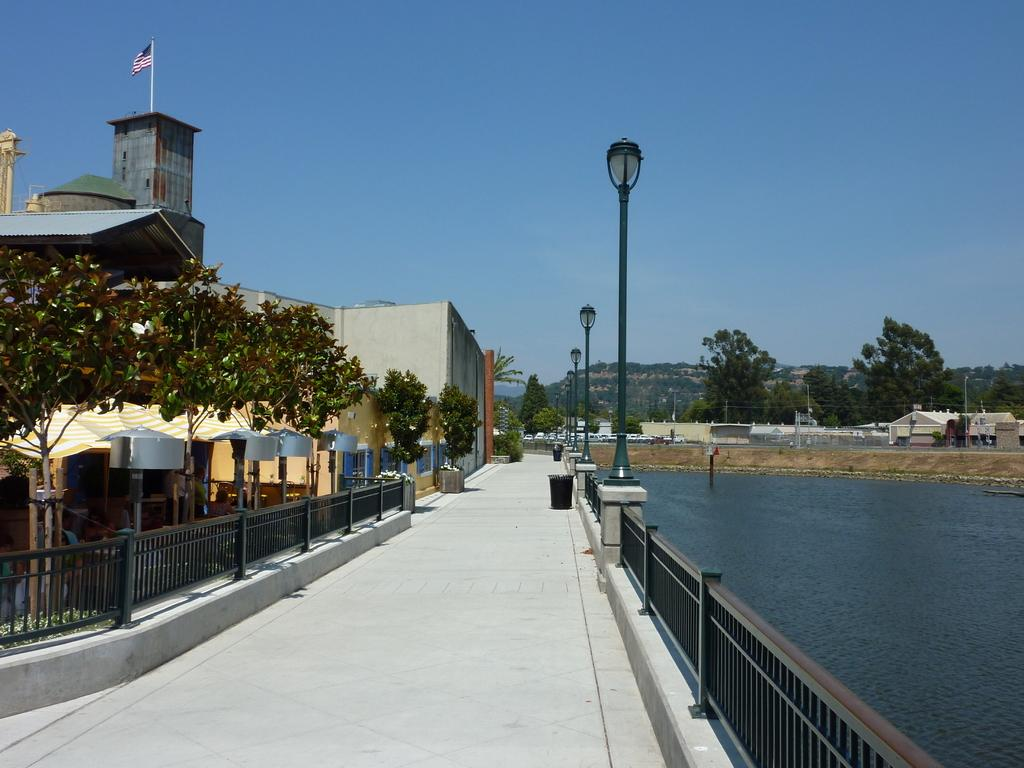What type of structures can be seen in the image? There are buildings, a shed, and street poles in the image. What additional features are present in the image? There is a flag, street lights, trees, iron grills, water, and the sky visible in the image. How many sisters are present in the image? There are no sisters present in the image; it features buildings, a shed, and other inanimate objects. What type of needle can be seen in the image? There is no needle present in the image. 